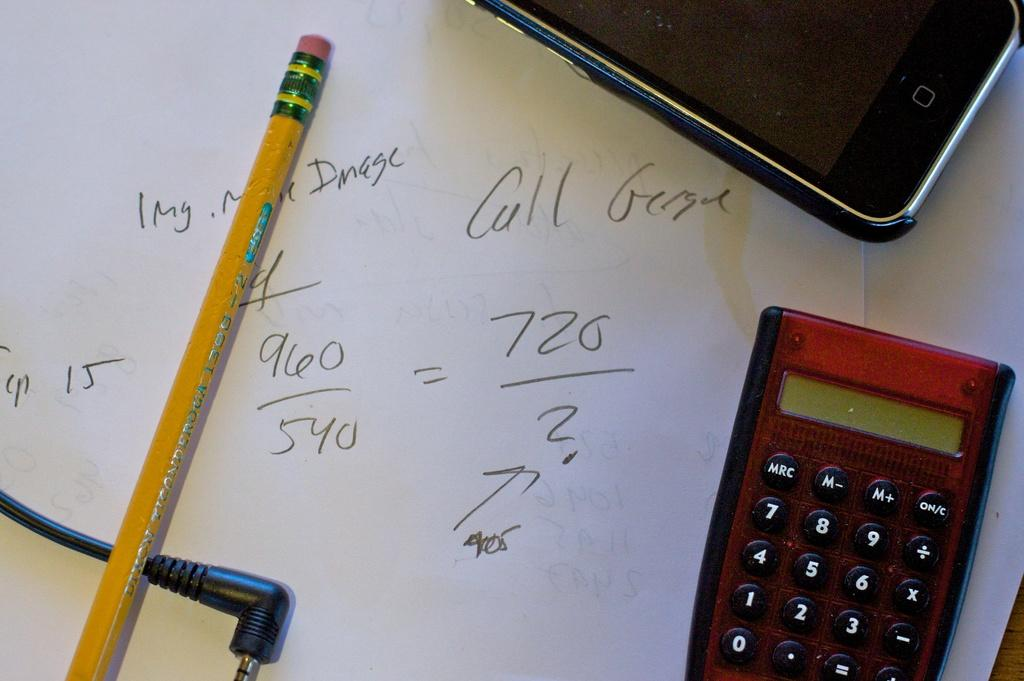<image>
Describe the image concisely. Red calculator on top of a piece of paper that says "Call George". 